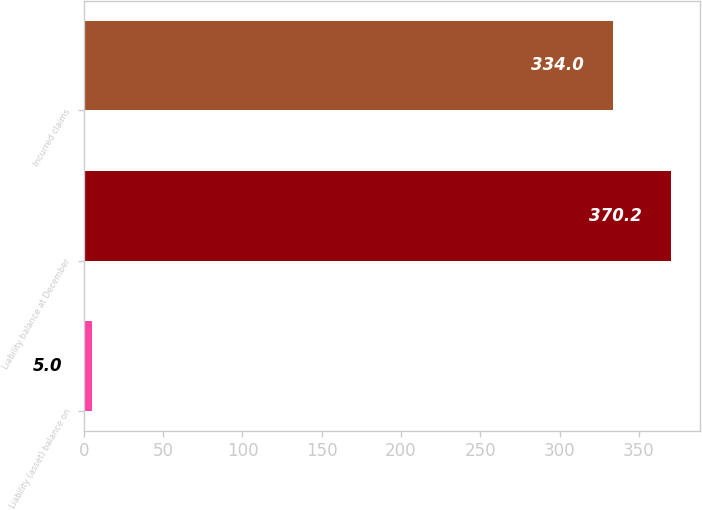Convert chart. <chart><loc_0><loc_0><loc_500><loc_500><bar_chart><fcel>Liability (asset) balance on<fcel>Liability balance at December<fcel>Incurred claims<nl><fcel>5<fcel>370.2<fcel>334<nl></chart> 